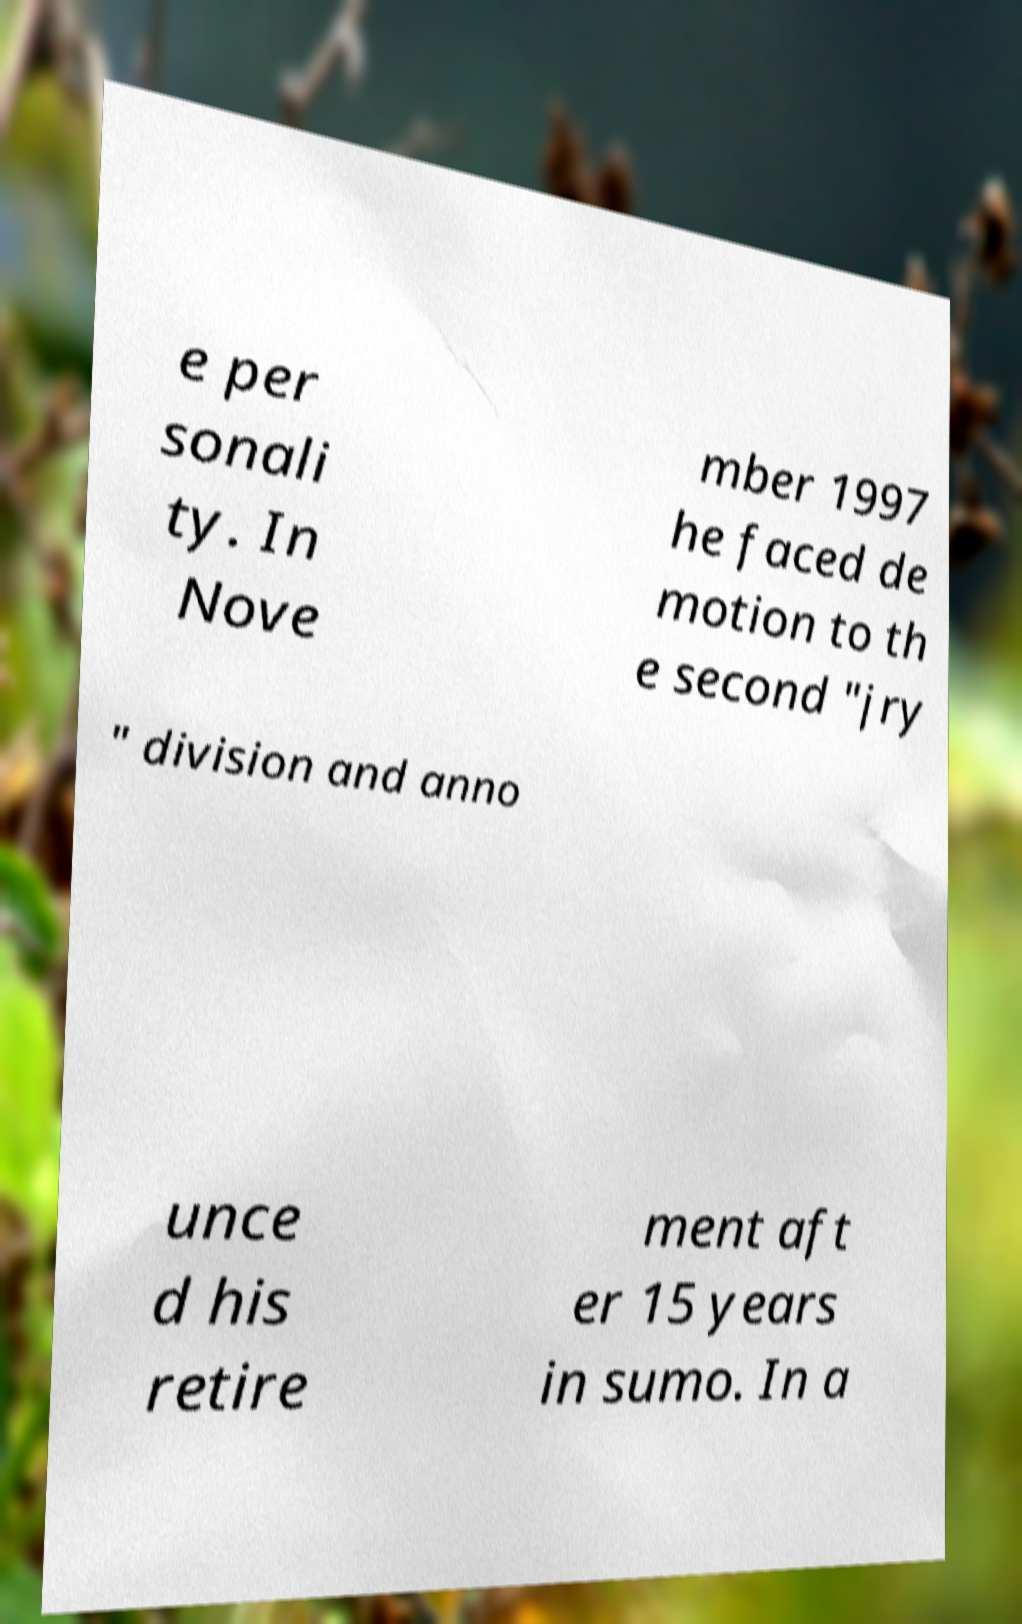Please read and relay the text visible in this image. What does it say? e per sonali ty. In Nove mber 1997 he faced de motion to th e second "jry " division and anno unce d his retire ment aft er 15 years in sumo. In a 